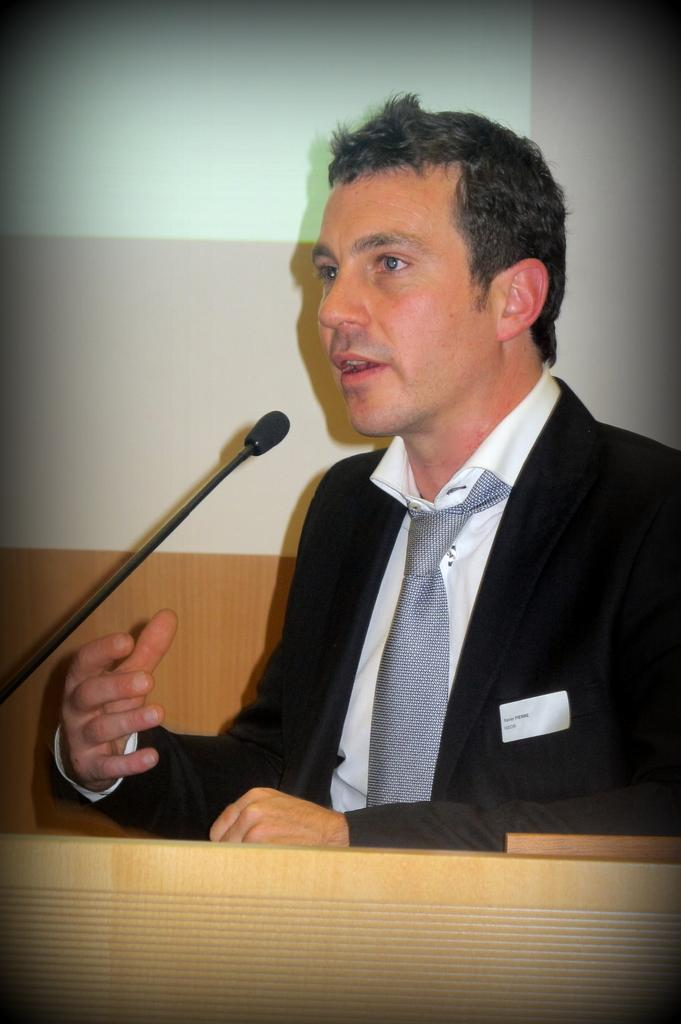What is the main subject of the image? There is a man in the image. What is the man wearing on his upper body? The man is wearing a black blazer and a white shirt. Is the man wearing any accessory around his neck? Yes, the man is wearing a tie. What is the color of the white object in the image? There is no specific information about the color of the white object in the image. What can be seen in the image that is used for amplifying sound? There is a microphone in the image. Can you tell me how many times the man sneezes in the image? There is no indication of the man sneezing in the image. What type of drum is visible on the stage in the image? There is no stage or drum present in the image. 